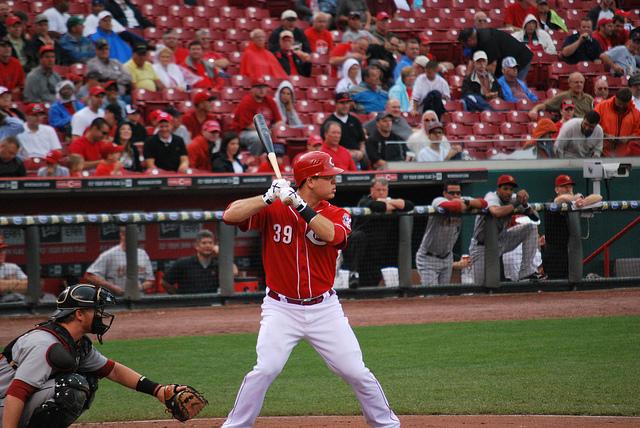What team is escobar playing for?
Keep it brief. Reds. Has the grass been watered?
Give a very brief answer. Yes. Is this man proud to be a baseball player?
Quick response, please. Yes. What team does this player likely play for?
Concise answer only. Cardinals. 